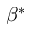Convert formula to latex. <formula><loc_0><loc_0><loc_500><loc_500>\beta ^ { * }</formula> 